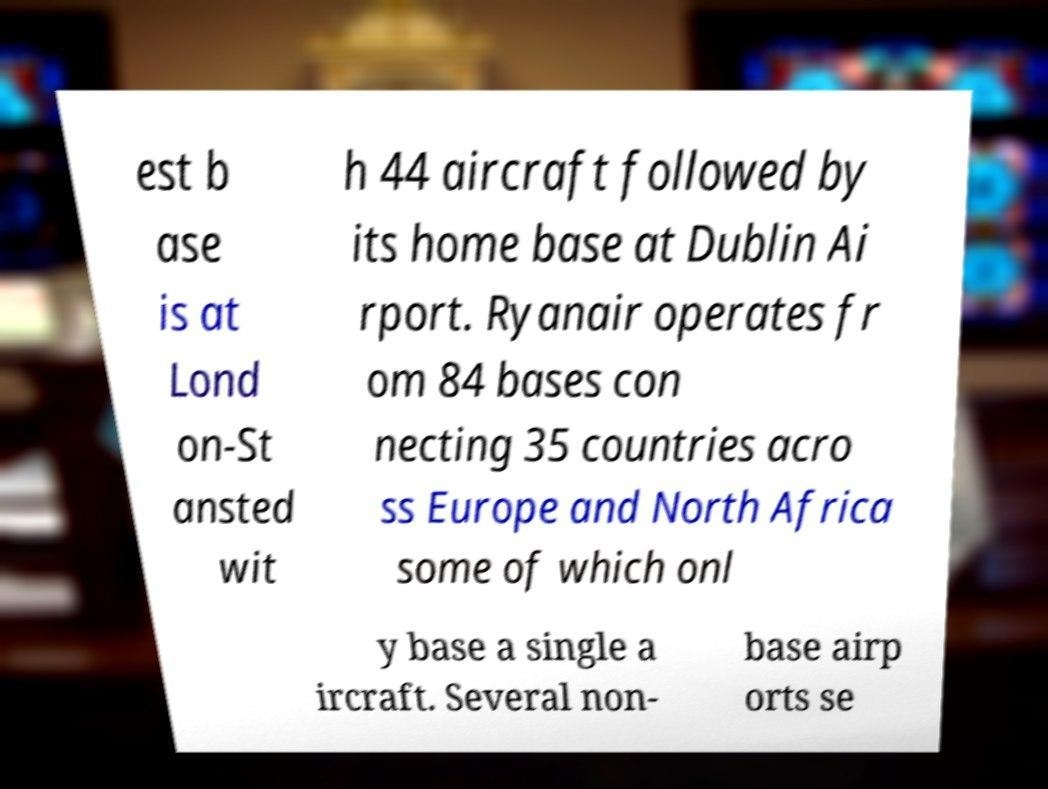Could you extract and type out the text from this image? est b ase is at Lond on-St ansted wit h 44 aircraft followed by its home base at Dublin Ai rport. Ryanair operates fr om 84 bases con necting 35 countries acro ss Europe and North Africa some of which onl y base a single a ircraft. Several non- base airp orts se 